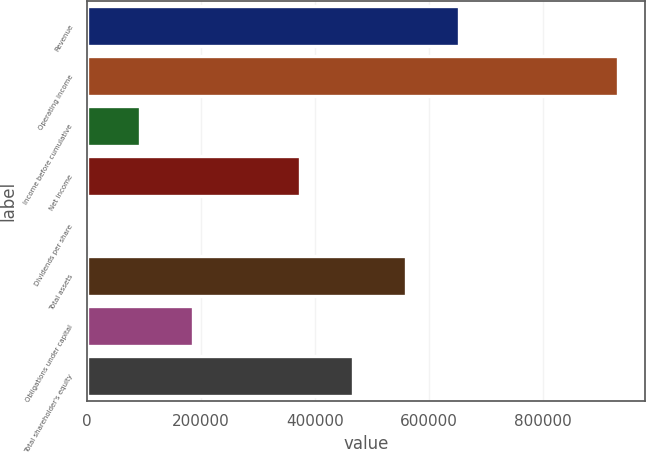Convert chart to OTSL. <chart><loc_0><loc_0><loc_500><loc_500><bar_chart><fcel>Revenue<fcel>Operating income<fcel>Income before cumulative<fcel>Net income<fcel>Dividends per share<fcel>Total assets<fcel>Obligations under capital<fcel>Total shareholder's equity<nl><fcel>652856<fcel>932651<fcel>93265.2<fcel>373060<fcel>0.16<fcel>559591<fcel>186530<fcel>466326<nl></chart> 